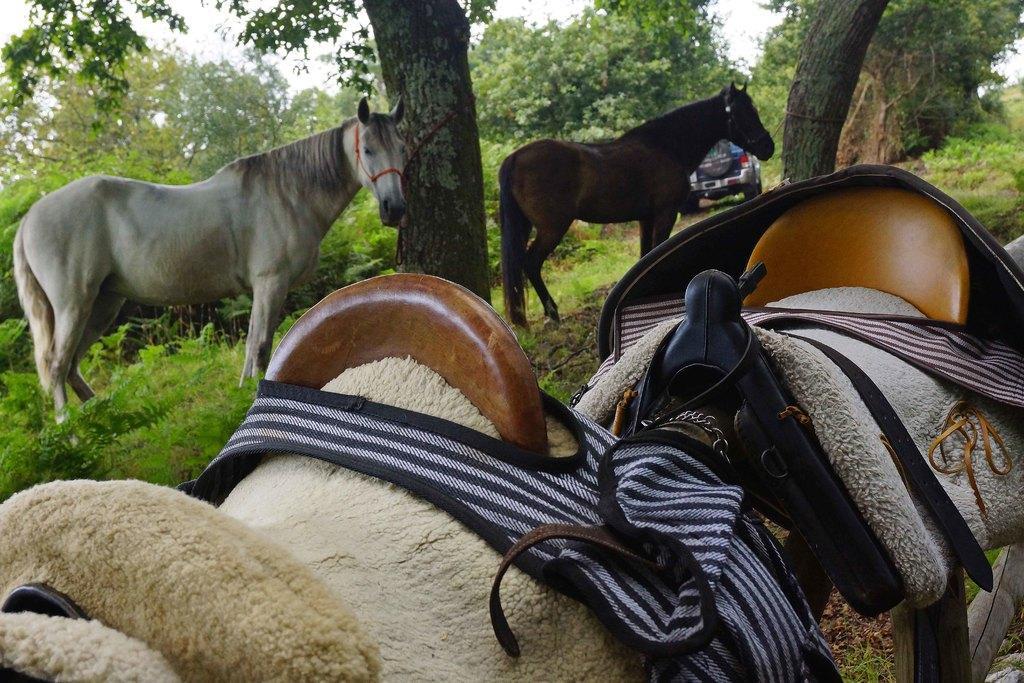Describe this image in one or two sentences. In this image I can see an open grass ground and on it I can see one white colour horse, one brown colour horse, number of trees and a vehicle. In the front I can see two horse seats, clothes and belts. I can also see the sky in the background. 